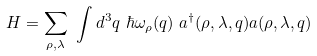Convert formula to latex. <formula><loc_0><loc_0><loc_500><loc_500>H = \sum _ { \rho , \lambda } \ \int d ^ { 3 } q \ \hbar { \omega } _ { \rho } ( { q } ) \ a ^ { \dag } ( \rho , \lambda , { q } ) a ( \rho , \lambda , { q } )</formula> 